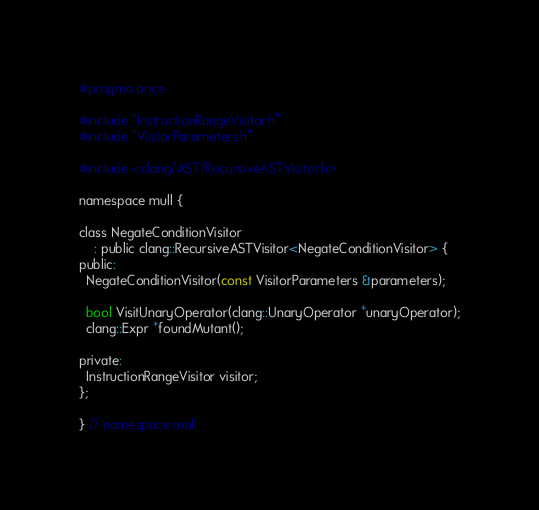<code> <loc_0><loc_0><loc_500><loc_500><_C_>#pragma once

#include "InstructionRangeVisitor.h"
#include "VisitorParameters.h"

#include <clang/AST/RecursiveASTVisitor.h>

namespace mull {

class NegateConditionVisitor
    : public clang::RecursiveASTVisitor<NegateConditionVisitor> {
public:
  NegateConditionVisitor(const VisitorParameters &parameters);

  bool VisitUnaryOperator(clang::UnaryOperator *unaryOperator);
  clang::Expr *foundMutant();

private:
  InstructionRangeVisitor visitor;
};

} // namespace mull</code> 